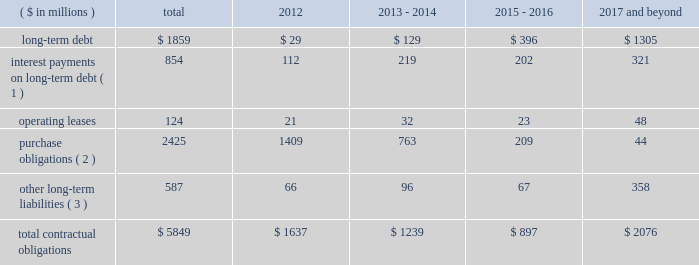Contractual obligations in 2011 , we issued $ 1200 million of senior notes and entered into the credit facility with third-party lenders in the amount of $ 1225 million .
As of december 31 , 2011 , total outstanding long-term debt was $ 1859 million , consisting of these senior notes and the credit facility , in addition to $ 105 million of third party debt that remained outstanding subsequent to the spin-off .
In connection with the spin-off , we entered into a transition services agreement with northrop grumman , under which northrop grumman or certain of its subsidiaries provides us with certain services to help ensure an orderly transition following the distribution .
Under the transition services agreement , northrop grumman provides , for up to 12 months following the spin-off , certain enterprise shared services ( including information technology , resource planning , financial , procurement and human resource services ) , benefits support services and other specified services .
The original term of the transition services agreement ends on march 31 , 2012 , although we have the right to and have cancelled certain services as we transition to new third-party providers .
The services provided by northrop grumman are charged to us at cost , and a limited number of these services may be extended for a period of approximately six months to allow full information systems transition .
See note 20 : related party transactions and former parent company equity in item 8 .
In connection with the spin-off , we entered into a tax matters agreement with northrop grumman ( the 201ctax matters agreement 201d ) that governs the respective rights , responsibilities and obligations of northrop grumman and us after the spin-off with respect to tax liabilities and benefits , tax attributes , tax contests and other tax sharing regarding u.s .
Federal , state , local and foreign income taxes , other taxes and related tax returns .
We have several liabilities with northrop grumman to the irs for the consolidated u.s .
Federal income taxes of the northrop grumman consolidated group relating to the taxable periods in which we were part of that group .
However , the tax matters agreement specifies the portion of this tax liability for which we will bear responsibility , and northrop grumman has agreed to indemnify us against any amounts for which we are not responsible .
The tax matters agreement also provides special rules for allocating tax liabilities in the event that the spin-off , together with certain related transactions , is not tax-free .
See note 20 : related party transactions and former parent company equity in item 8 .
We do not expect either the transition services agreement or the tax matters agreement to have a significant impact on our financial condition and results of operations .
The table presents our contractual obligations as of december 31 , 2011 , and the related estimated timing of future cash payments : ( $ in millions ) total 2012 2013 - 2014 2015 - 2016 2017 and beyond .
( 1 ) interest payments include interest on $ 554 million of variable interest rate debt calculated based on interest rates at december 31 , 2011 .
( 2 ) a 201cpurchase obligation 201d is defined as an agreement to purchase goods or services that is enforceable and legally binding on us and that specifies all significant terms , including : fixed or minimum quantities to be purchased ; fixed , minimum , or variable price provisions ; and the approximate timing of the transaction .
These amounts are primarily comprised of open purchase order commitments to vendors and subcontractors pertaining to funded contracts .
( 3 ) other long-term liabilities primarily consist of total accrued workers 2019 compensation reserves , deferred compensation , and other miscellaneous liabilities , of which $ 201 million is the current portion of workers 2019 compensation liabilities .
It excludes obligations for uncertain tax positions of $ 9 million , as the timing of the payments , if any , cannot be reasonably estimated .
The above table excludes retirement related contributions .
In 2012 , we expect to make minimum and discretionary contributions to our qualified pension plans of approximately $ 153 million and $ 65 million , respectively , exclusive of any u.s .
Government recoveries .
We will continue to periodically evaluate whether to make additional discretionary contributions .
In 2012 , we expect to make $ 35 million in contributions for our other postretirement plans , exclusive of any .
In 2012 what is the ratio of the minimum to the discretionary contributions to our qualified pension plans? 
Rationale: for every 2.35 of the minimum required payments $ 1 is spent on the discretionary payments
Computations: (153 / 65)
Answer: 2.35385. 